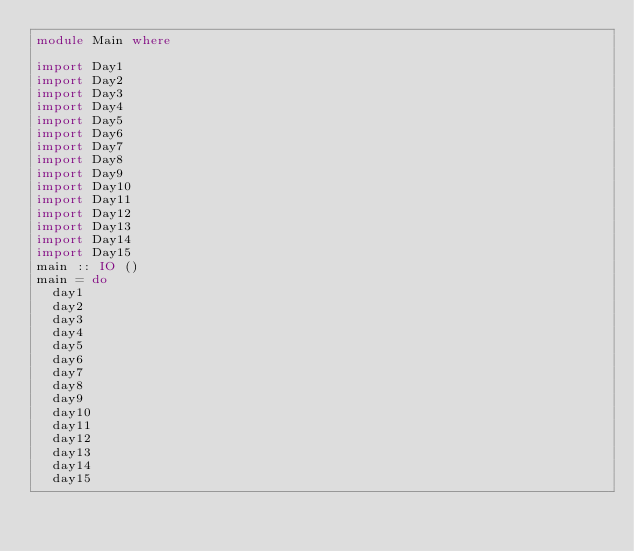<code> <loc_0><loc_0><loc_500><loc_500><_Haskell_>module Main where

import Day1
import Day2
import Day3
import Day4
import Day5
import Day6
import Day7
import Day8
import Day9
import Day10
import Day11
import Day12
import Day13
import Day14
import Day15
main :: IO ()
main = do
  day1
  day2
  day3
  day4
  day5
  day6
  day7
  day8
  day9
  day10
  day11
  day12
  day13
  day14
  day15
</code> 